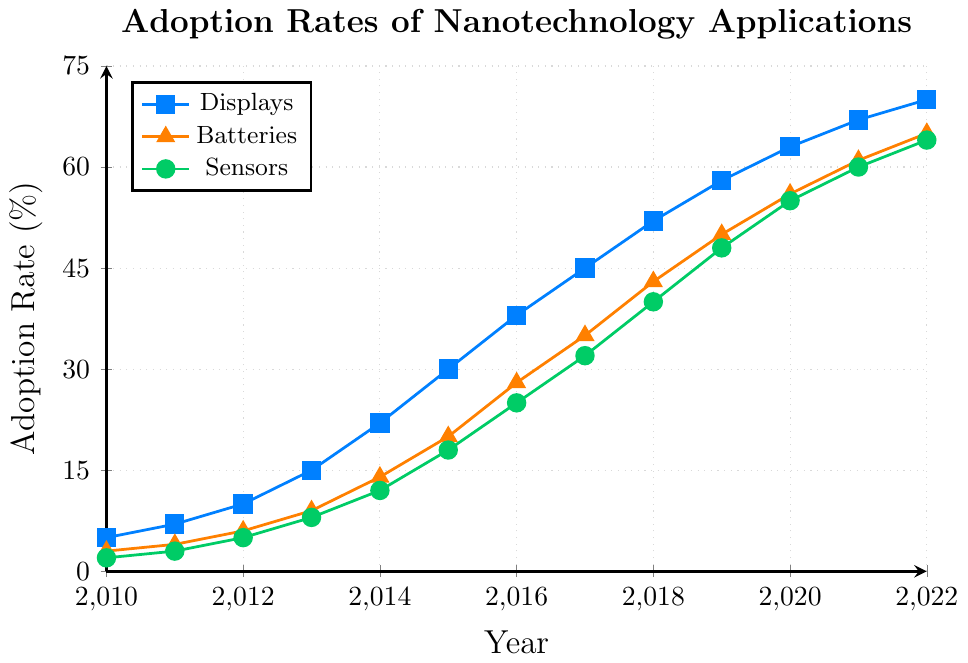What was the adoption rate of displays in 2016? In 2016, look at the point on the blue line (displays line) and read the value on the y-axis where it intersects.
Answer: 38 Which application had the highest adoption rate in 2014? Compare the y-axis values for displays, batteries, and sensors in 2014. The highest value is for displays.
Answer: Displays By how much did the adoption rate of batteries increase from 2011 to 2015? Subtract the adoption rate in 2011 (4%) from the adoption rate in 2015 (20%) for batteries.
Answer: 16 What is the average adoption rate of sensors from 2010 to 2012? Find the adoption rates for 2010 (2%), 2011 (3%), and 2012 (5%). Calculate the average: (2 + 3 + 5) / 3.
Answer: 3.33 In which year did displays surpass a 50% adoption rate? Check the point on the blue line representing displays where the adoption rate first exceeds 50%. This occurs in 2018.
Answer: 2018 How does the adoption rate trend for sensors compare to batteries from 2013 to 2017? Compare the slopes of the green line (sensors) and the orange line (batteries) from 2013 to 2017. Both lines increase, but batteries generally have a higher adoption rate each year within this period.
Answer: Batteries have higher rates What is the difference between the adoption rates of displays and sensors in 2022? Subtract the adoption rate of sensors (64%) from displays (70%) for the year 2022.
Answer: 6 Which application shows the steepest increase in adoption rate between 2015 and 2016? Compare the slopes of lines (displays, batteries, and sensors) between 2015 and 2016. Displays increase by 8%, batteries by 8%, and sensors by 7%. Both displays and batteries show the steepest increase.
Answer: Displays and Batteries From 2010 to 2022, which application consistently had the lowest adoption rate? Check the values of all three applications over the years. Sensors consistently have the lowest adoption rate from 2010 to 2022.
Answer: Sensors What visual attributes differentiate the adoption rates of displays and sensors on the plot? The adoption rate of displays is represented by a blue line with square markers, while sensors have a green line with circular markers.
Answer: Color and Marker Shape 